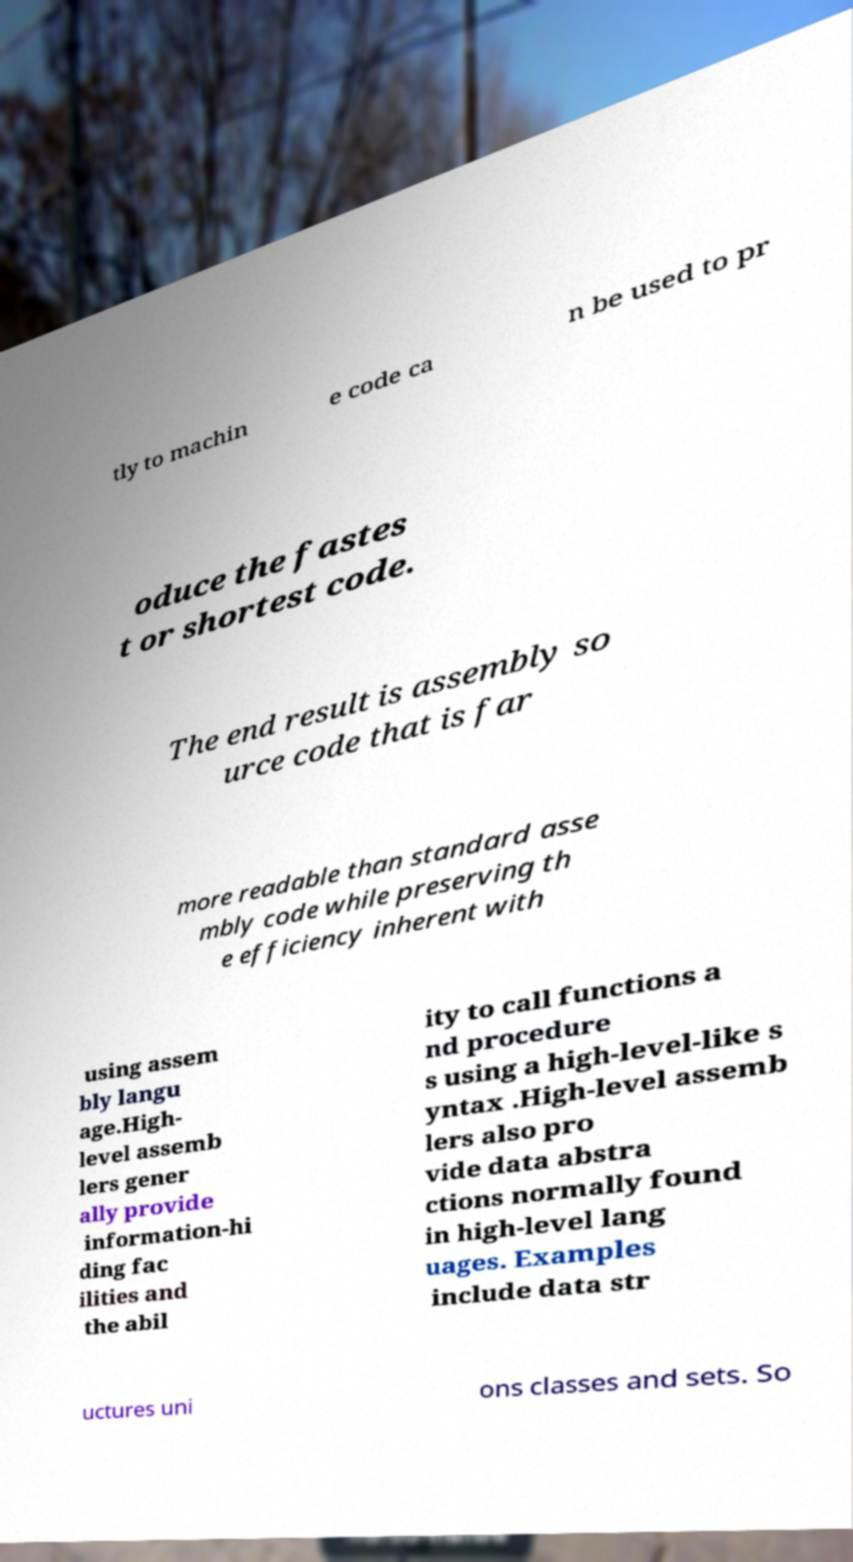Could you assist in decoding the text presented in this image and type it out clearly? tly to machin e code ca n be used to pr oduce the fastes t or shortest code. The end result is assembly so urce code that is far more readable than standard asse mbly code while preserving th e efficiency inherent with using assem bly langu age.High- level assemb lers gener ally provide information-hi ding fac ilities and the abil ity to call functions a nd procedure s using a high-level-like s yntax .High-level assemb lers also pro vide data abstra ctions normally found in high-level lang uages. Examples include data str uctures uni ons classes and sets. So 